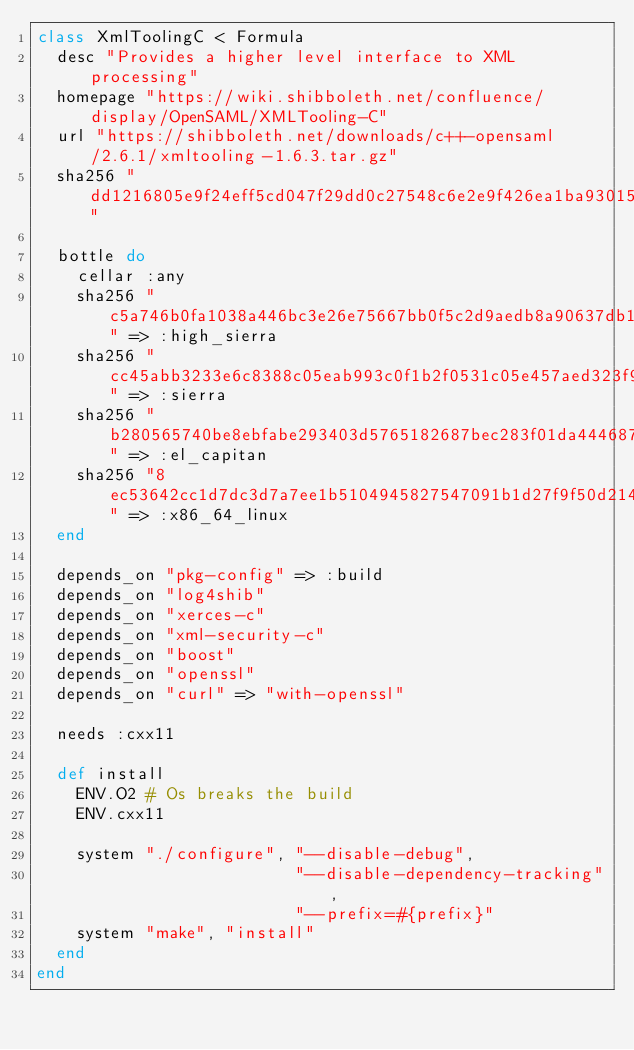<code> <loc_0><loc_0><loc_500><loc_500><_Ruby_>class XmlToolingC < Formula
  desc "Provides a higher level interface to XML processing"
  homepage "https://wiki.shibboleth.net/confluence/display/OpenSAML/XMLTooling-C"
  url "https://shibboleth.net/downloads/c++-opensaml/2.6.1/xmltooling-1.6.3.tar.gz"
  sha256 "dd1216805e9f24eff5cd047f29dd0c27548c6e2e9f426ea1ba930150a88010f9"

  bottle do
    cellar :any
    sha256 "c5a746b0fa1038a446bc3e26e75667bb0f5c2d9aedb8a90637db1e9522e9610d" => :high_sierra
    sha256 "cc45abb3233e6c8388c05eab993c0f1b2f0531c05e457aed323f9f1c1a32fd23" => :sierra
    sha256 "b280565740be8ebfabe293403d5765182687bec283f01da44468730e7f80006d" => :el_capitan
    sha256 "8ec53642cc1d7dc3d7a7ee1b5104945827547091b1d27f9f50d214aae24e50e2" => :x86_64_linux
  end

  depends_on "pkg-config" => :build
  depends_on "log4shib"
  depends_on "xerces-c"
  depends_on "xml-security-c"
  depends_on "boost"
  depends_on "openssl"
  depends_on "curl" => "with-openssl"

  needs :cxx11

  def install
    ENV.O2 # Os breaks the build
    ENV.cxx11

    system "./configure", "--disable-debug",
                          "--disable-dependency-tracking",
                          "--prefix=#{prefix}"
    system "make", "install"
  end
end
</code> 